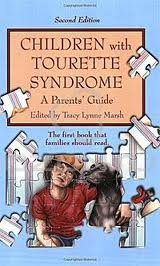What is the genre of this book? The genre of this book falls under Health, specifically targeting parents with authoritative advice on managing Tourette Syndrome in children. 